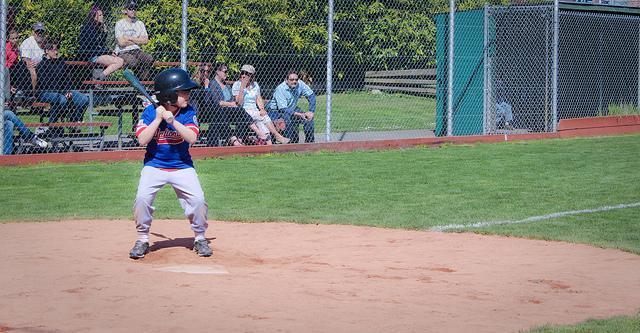How many people are there?
Give a very brief answer. 3. 